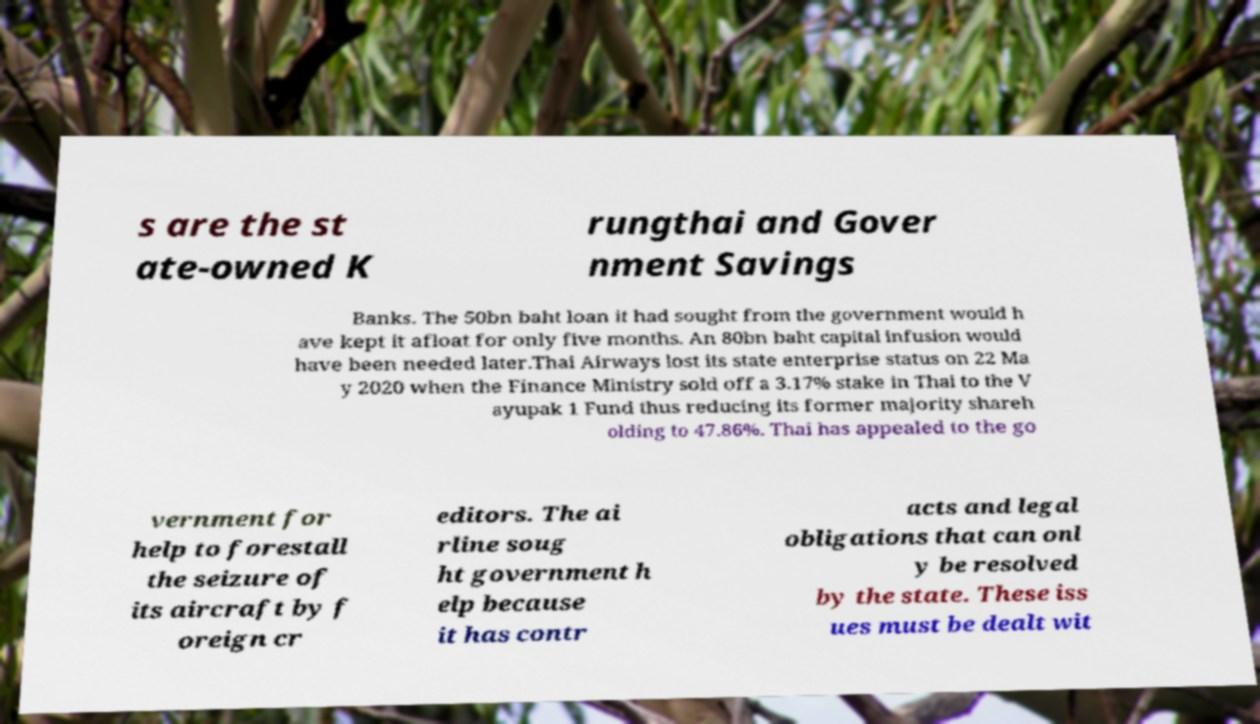Please identify and transcribe the text found in this image. s are the st ate-owned K rungthai and Gover nment Savings Banks. The 50bn baht loan it had sought from the government would h ave kept it afloat for only five months. An 80bn baht capital infusion would have been needed later.Thai Airways lost its state enterprise status on 22 Ma y 2020 when the Finance Ministry sold off a 3.17% stake in Thai to the V ayupak 1 Fund thus reducing its former majority shareh olding to 47.86%. Thai has appealed to the go vernment for help to forestall the seizure of its aircraft by f oreign cr editors. The ai rline soug ht government h elp because it has contr acts and legal obligations that can onl y be resolved by the state. These iss ues must be dealt wit 